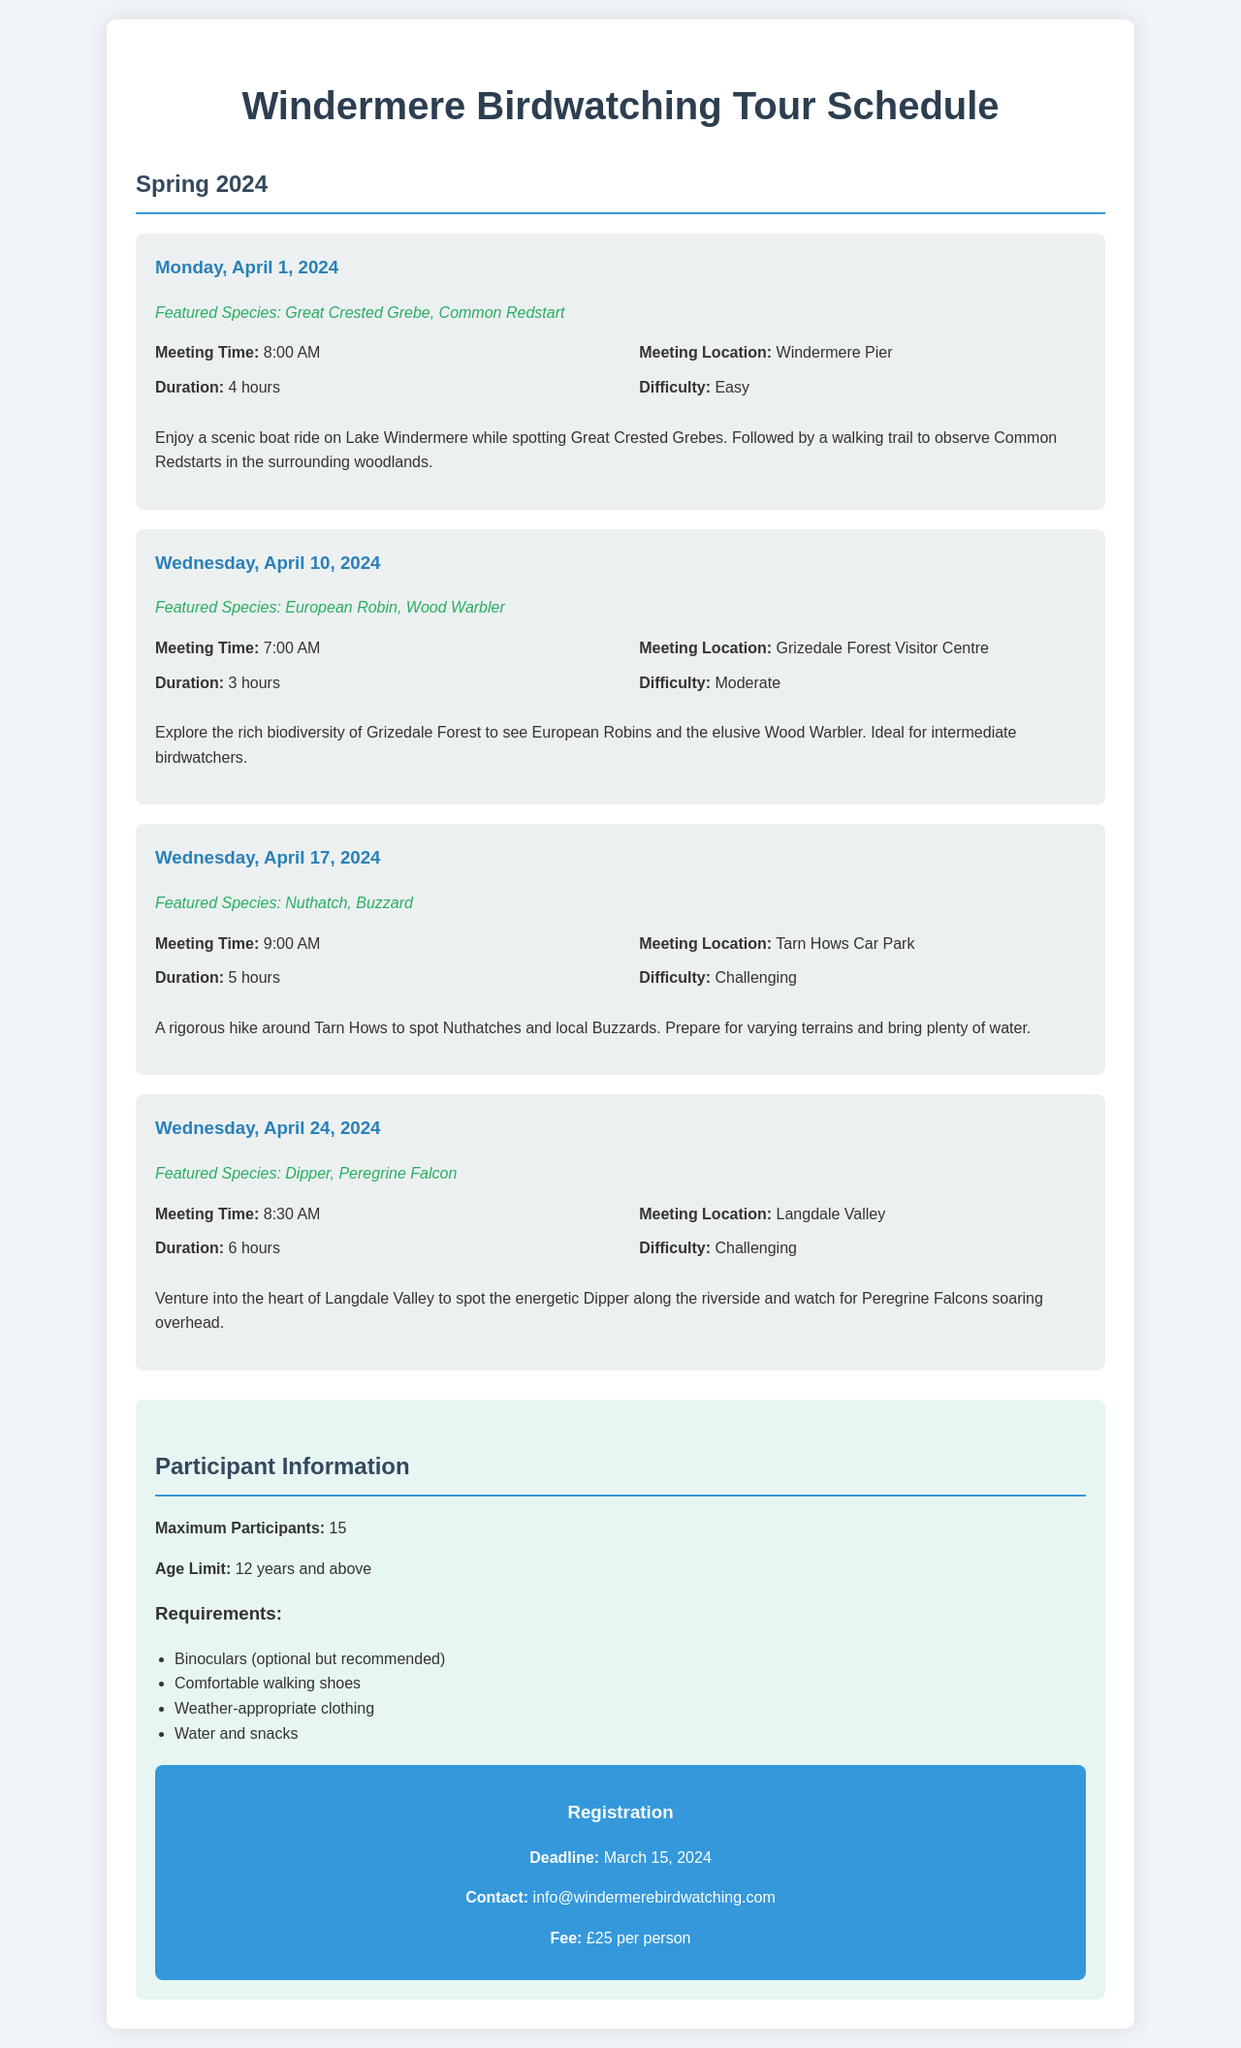what is the meeting location for the April 1 excursion? The meeting location for the April 1 excursion is Windermere Pier.
Answer: Windermere Pier what is the featured species for the April 10 excursion? The featured species for the April 10 excursion are European Robin and Wood Warbler.
Answer: European Robin, Wood Warbler how many hours is the April 24 excursion? The duration of the April 24 excursion is 6 hours.
Answer: 6 hours what is the maximum number of participants allowed? The document states that the maximum number of participants is 15.
Answer: 15 what is the age limit for participants? The age limit for participants is stated to be 12 years and above.
Answer: 12 years and above which excursion has a difficulty level of "Challenging"? The excursions on April 17 and April 24 are marked as "Challenging."
Answer: April 17, April 24 when is the registration deadline? The registration deadline is March 15, 2024.
Answer: March 15, 2024 what is the fee per person for the tour? The fee per person for the tour is £25.
Answer: £25 what should participants bring to the excursions? Participants should bring binoculars, comfortable walking shoes, weather-appropriate clothing, water, and snacks.
Answer: Binoculars, comfortable walking shoes, weather-appropriate clothing, water, snacks 